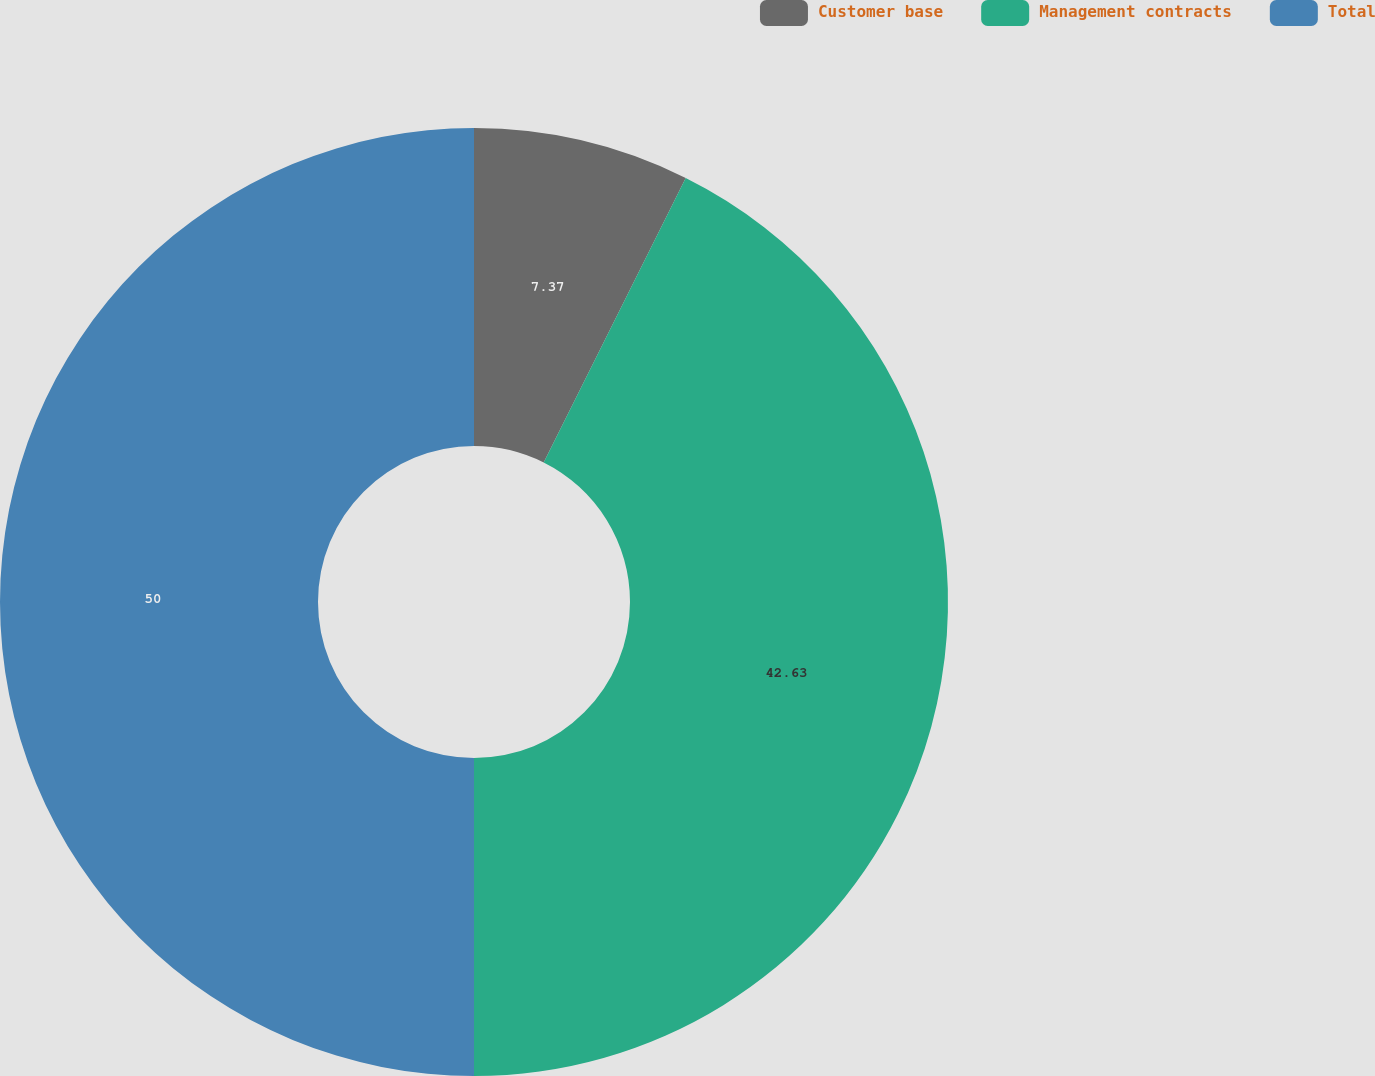<chart> <loc_0><loc_0><loc_500><loc_500><pie_chart><fcel>Customer base<fcel>Management contracts<fcel>Total<nl><fcel>7.37%<fcel>42.63%<fcel>50.0%<nl></chart> 